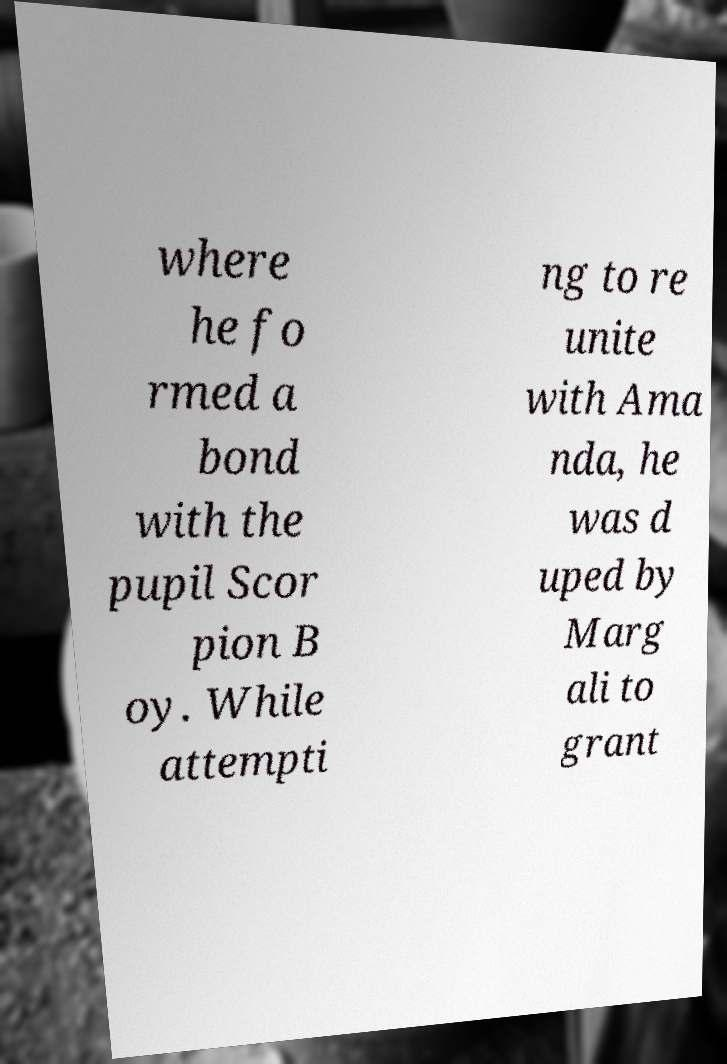There's text embedded in this image that I need extracted. Can you transcribe it verbatim? where he fo rmed a bond with the pupil Scor pion B oy. While attempti ng to re unite with Ama nda, he was d uped by Marg ali to grant 